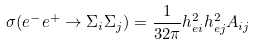<formula> <loc_0><loc_0><loc_500><loc_500>\sigma ( e ^ { - } e ^ { + } \rightarrow \Sigma _ { i } \Sigma _ { j } ) = \frac { 1 } { 3 2 \pi } h ^ { 2 } _ { e i } h ^ { 2 } _ { e j } A _ { i j }</formula> 